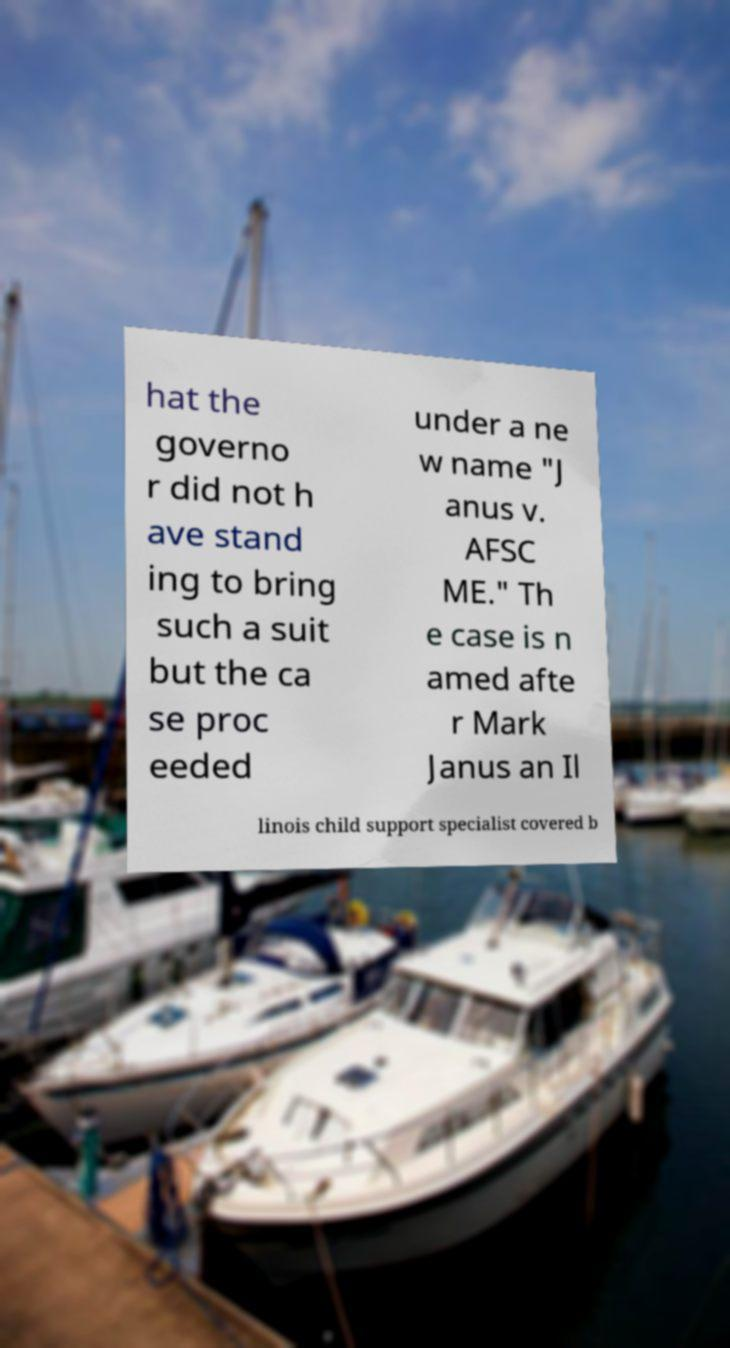Please read and relay the text visible in this image. What does it say? hat the governo r did not h ave stand ing to bring such a suit but the ca se proc eeded under a ne w name "J anus v. AFSC ME." Th e case is n amed afte r Mark Janus an Il linois child support specialist covered b 